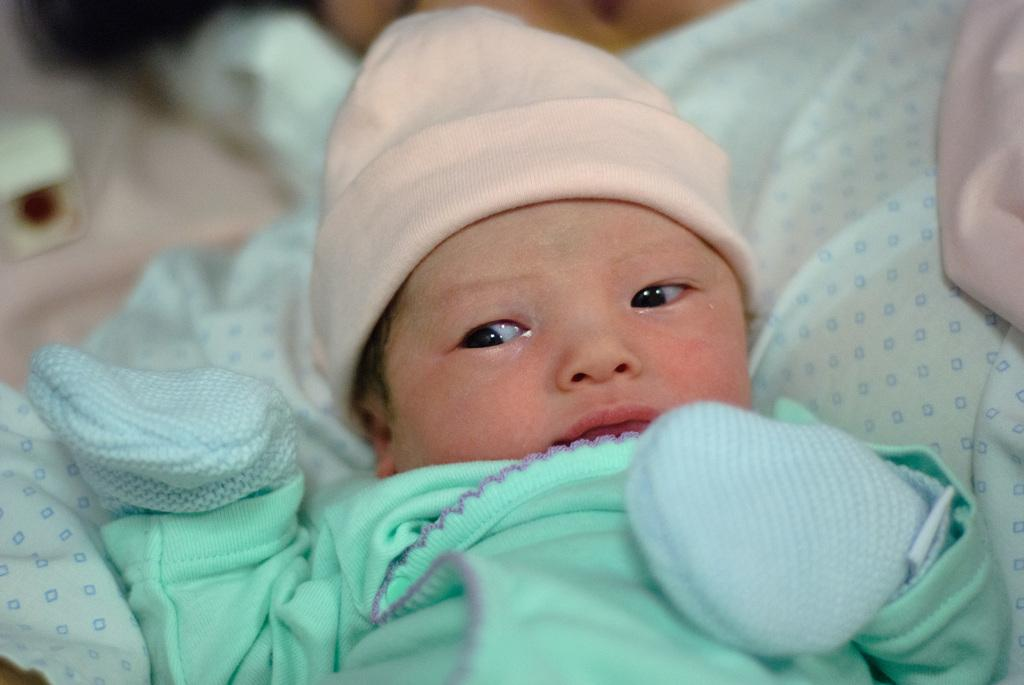What is the main subject of the image? There is a baby in the image. What accessories is the baby wearing? The baby is wearing gloves and a cap. Can you describe the background of the image? There is a cloth visible in the background of the image. What type of scent can be detected from the baby in the image? There is no information about the scent of the baby in the image. 